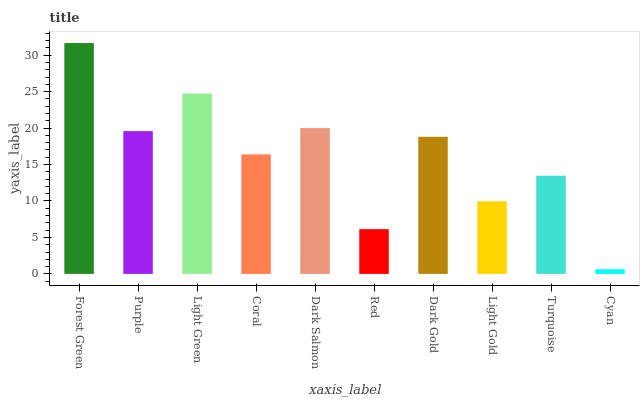Is Cyan the minimum?
Answer yes or no. Yes. Is Forest Green the maximum?
Answer yes or no. Yes. Is Purple the minimum?
Answer yes or no. No. Is Purple the maximum?
Answer yes or no. No. Is Forest Green greater than Purple?
Answer yes or no. Yes. Is Purple less than Forest Green?
Answer yes or no. Yes. Is Purple greater than Forest Green?
Answer yes or no. No. Is Forest Green less than Purple?
Answer yes or no. No. Is Dark Gold the high median?
Answer yes or no. Yes. Is Coral the low median?
Answer yes or no. Yes. Is Light Gold the high median?
Answer yes or no. No. Is Light Green the low median?
Answer yes or no. No. 